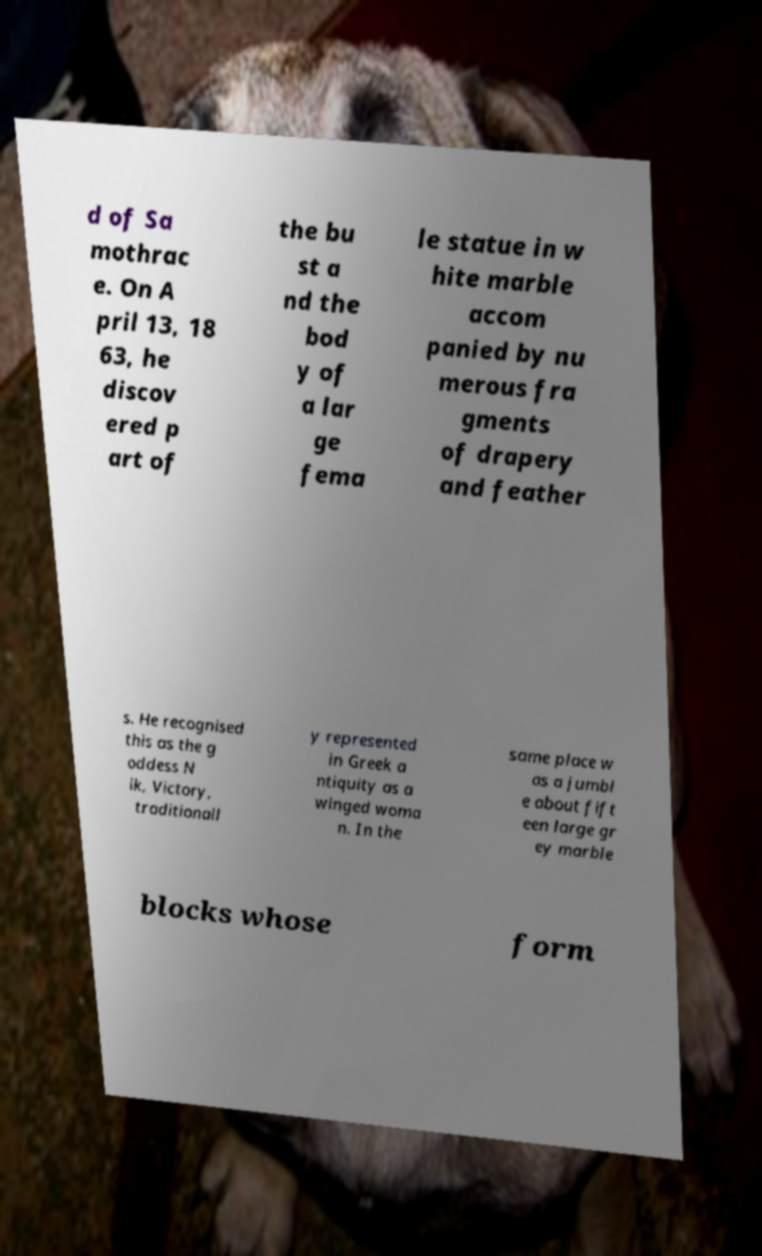I need the written content from this picture converted into text. Can you do that? d of Sa mothrac e. On A pril 13, 18 63, he discov ered p art of the bu st a nd the bod y of a lar ge fema le statue in w hite marble accom panied by nu merous fra gments of drapery and feather s. He recognised this as the g oddess N ik, Victory, traditionall y represented in Greek a ntiquity as a winged woma n. In the same place w as a jumbl e about fift een large gr ey marble blocks whose form 